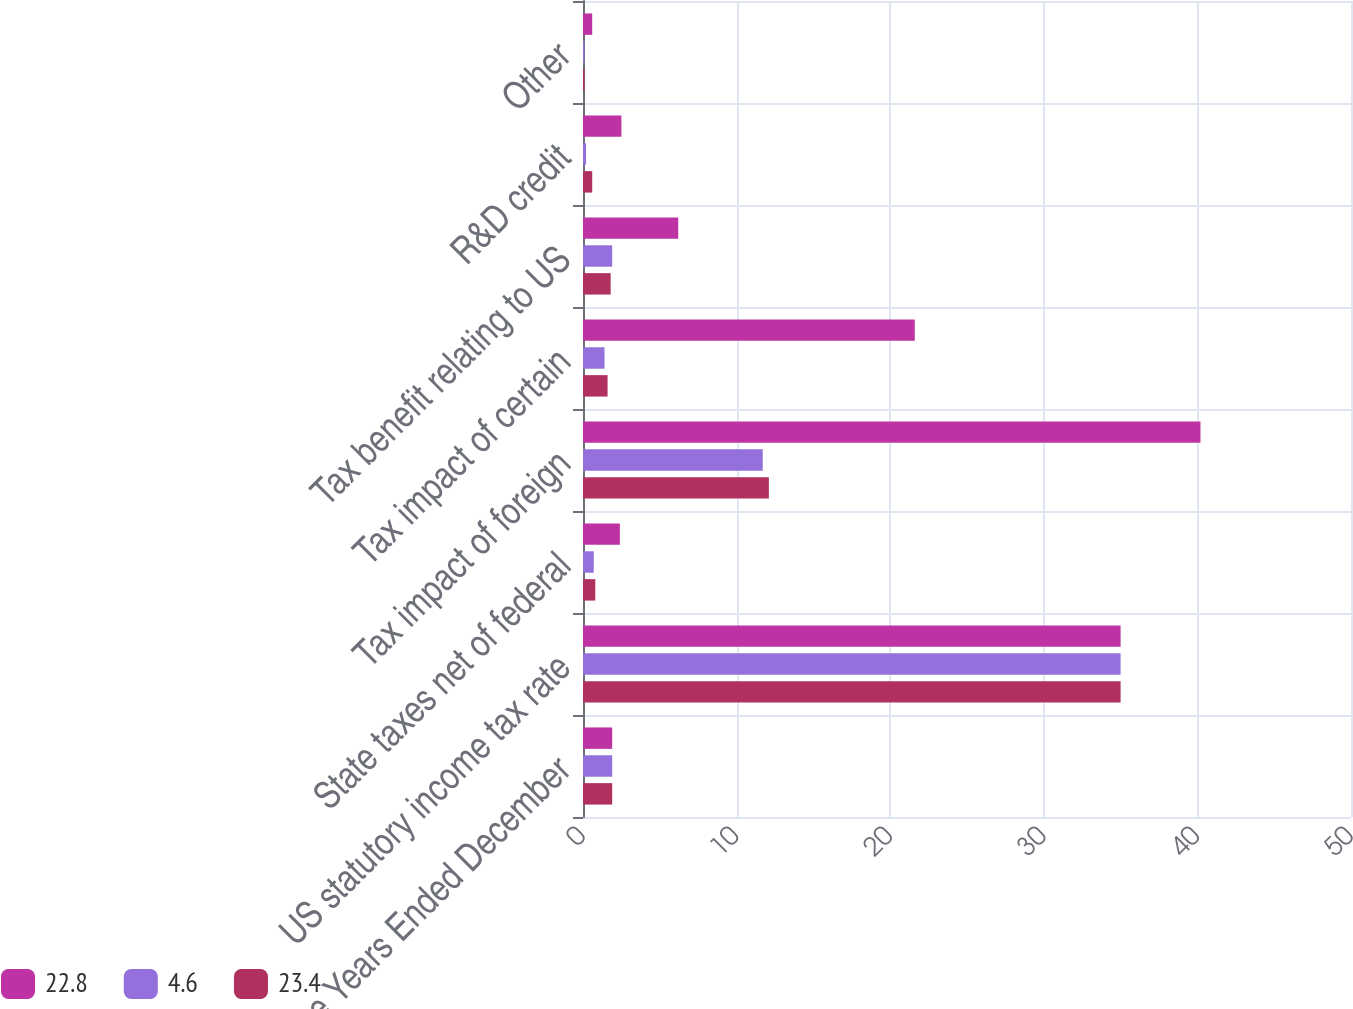Convert chart. <chart><loc_0><loc_0><loc_500><loc_500><stacked_bar_chart><ecel><fcel>For the Years Ended December<fcel>US statutory income tax rate<fcel>State taxes net of federal<fcel>Tax impact of foreign<fcel>Tax impact of certain<fcel>Tax benefit relating to US<fcel>R&D credit<fcel>Other<nl><fcel>22.8<fcel>1.9<fcel>35<fcel>2.4<fcel>40.2<fcel>21.6<fcel>6.2<fcel>2.5<fcel>0.6<nl><fcel>4.6<fcel>1.9<fcel>35<fcel>0.7<fcel>11.7<fcel>1.4<fcel>1.9<fcel>0.2<fcel>0.1<nl><fcel>23.4<fcel>1.9<fcel>35<fcel>0.8<fcel>12.1<fcel>1.6<fcel>1.8<fcel>0.6<fcel>0.1<nl></chart> 